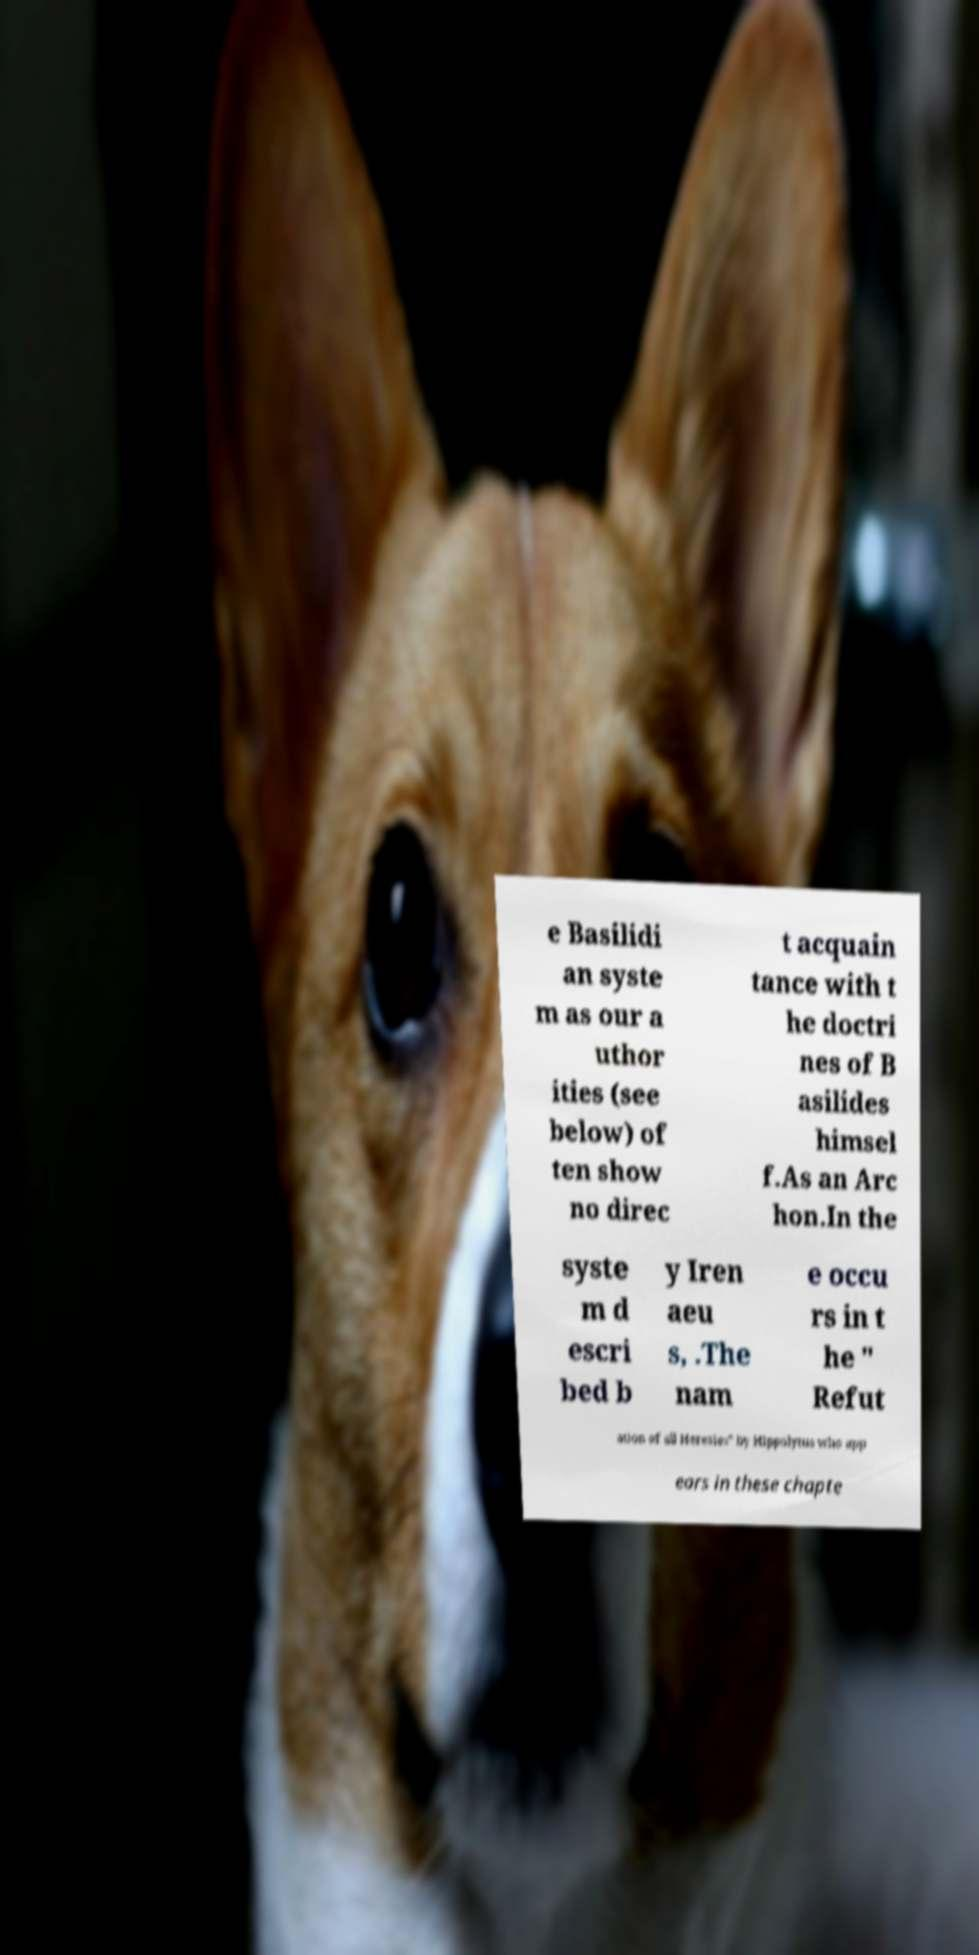Could you assist in decoding the text presented in this image and type it out clearly? e Basilidi an syste m as our a uthor ities (see below) of ten show no direc t acquain tance with t he doctri nes of B asilides himsel f.As an Arc hon.In the syste m d escri bed b y Iren aeu s, .The nam e occu rs in t he " Refut ation of all Heresies" by Hippolytus who app ears in these chapte 